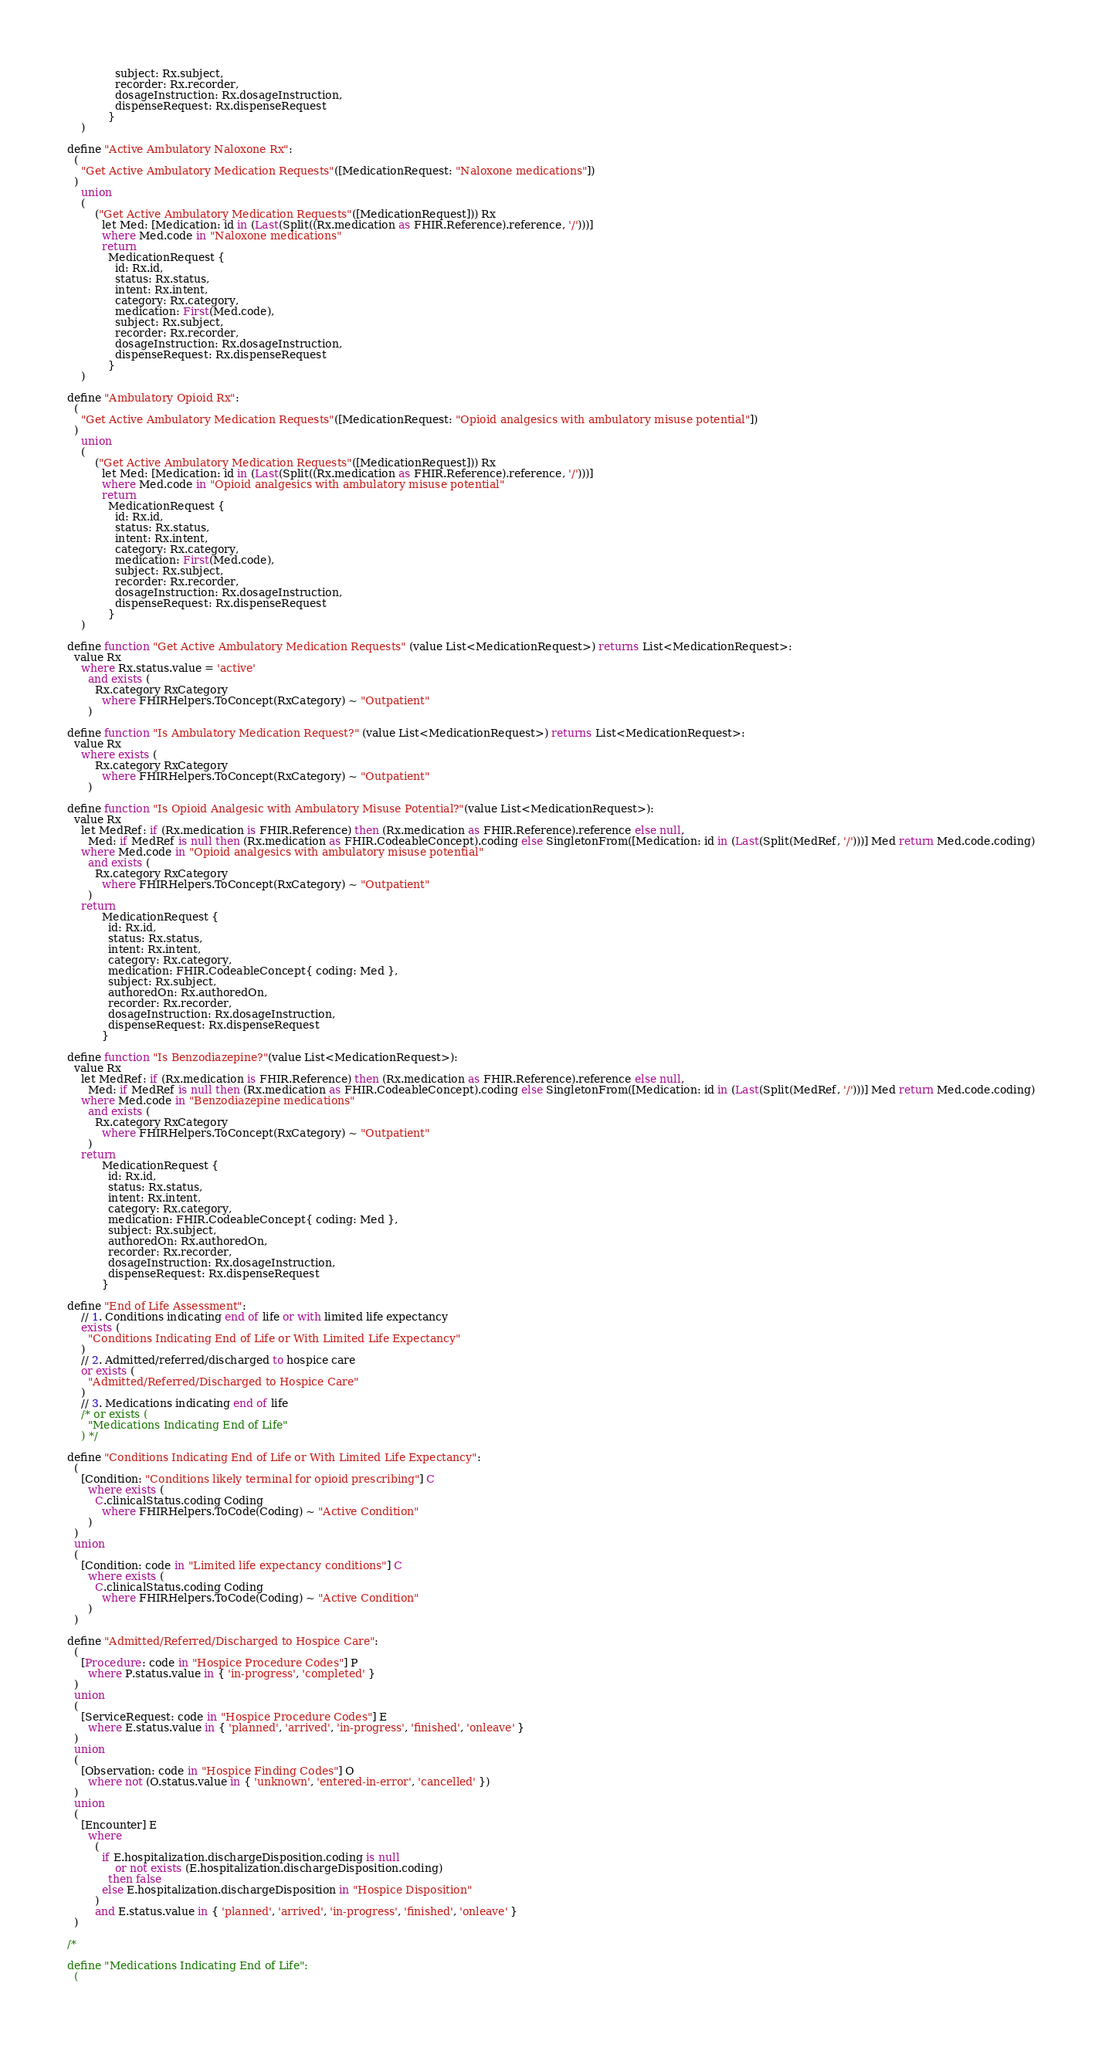<code> <loc_0><loc_0><loc_500><loc_500><_SQL_>              subject: Rx.subject,
              recorder: Rx.recorder,
              dosageInstruction: Rx.dosageInstruction,
              dispenseRequest: Rx.dispenseRequest
            }
    )

define "Active Ambulatory Naloxone Rx":
  (
    "Get Active Ambulatory Medication Requests"([MedicationRequest: "Naloxone medications"])
  )
    union
    (
        ("Get Active Ambulatory Medication Requests"([MedicationRequest])) Rx
          let Med: [Medication: id in (Last(Split((Rx.medication as FHIR.Reference).reference, '/')))]
          where Med.code in "Naloxone medications"
          return
            MedicationRequest {
              id: Rx.id,
              status: Rx.status,
              intent: Rx.intent,
              category: Rx.category,
              medication: First(Med.code),
              subject: Rx.subject,
              recorder: Rx.recorder,
              dosageInstruction: Rx.dosageInstruction,
              dispenseRequest: Rx.dispenseRequest
            }
    )

define "Ambulatory Opioid Rx":
  (
    "Get Active Ambulatory Medication Requests"([MedicationRequest: "Opioid analgesics with ambulatory misuse potential"])
  )
    union
    (
        ("Get Active Ambulatory Medication Requests"([MedicationRequest])) Rx
          let Med: [Medication: id in (Last(Split((Rx.medication as FHIR.Reference).reference, '/')))]
          where Med.code in "Opioid analgesics with ambulatory misuse potential"
          return
            MedicationRequest {
              id: Rx.id,
              status: Rx.status,
              intent: Rx.intent,
              category: Rx.category,
              medication: First(Med.code),
              subject: Rx.subject,
              recorder: Rx.recorder,
              dosageInstruction: Rx.dosageInstruction,
              dispenseRequest: Rx.dispenseRequest
            }
    )

define function "Get Active Ambulatory Medication Requests" (value List<MedicationRequest>) returns List<MedicationRequest>:
  value Rx
    where Rx.status.value = 'active'
      and exists (
        Rx.category RxCategory
          where FHIRHelpers.ToConcept(RxCategory) ~ "Outpatient"
      )

define function "Is Ambulatory Medication Request?" (value List<MedicationRequest>) returns List<MedicationRequest>:
  value Rx
    where exists (
        Rx.category RxCategory
          where FHIRHelpers.ToConcept(RxCategory) ~ "Outpatient"
      )

define function "Is Opioid Analgesic with Ambulatory Misuse Potential?"(value List<MedicationRequest>):
  value Rx
    let MedRef: if (Rx.medication is FHIR.Reference) then (Rx.medication as FHIR.Reference).reference else null,
      Med: if MedRef is null then (Rx.medication as FHIR.CodeableConcept).coding else SingletonFrom([Medication: id in (Last(Split(MedRef, '/')))] Med return Med.code.coding)
    where Med.code in "Opioid analgesics with ambulatory misuse potential"
      and exists (
        Rx.category RxCategory
          where FHIRHelpers.ToConcept(RxCategory) ~ "Outpatient"
      )
    return
          MedicationRequest {
            id: Rx.id,
            status: Rx.status,
            intent: Rx.intent,
            category: Rx.category,
            medication: FHIR.CodeableConcept{ coding: Med },
            subject: Rx.subject,
            authoredOn: Rx.authoredOn,
            recorder: Rx.recorder,
            dosageInstruction: Rx.dosageInstruction,
            dispenseRequest: Rx.dispenseRequest
          }

define function "Is Benzodiazepine?"(value List<MedicationRequest>):
  value Rx
    let MedRef: if (Rx.medication is FHIR.Reference) then (Rx.medication as FHIR.Reference).reference else null,
      Med: if MedRef is null then (Rx.medication as FHIR.CodeableConcept).coding else SingletonFrom([Medication: id in (Last(Split(MedRef, '/')))] Med return Med.code.coding)
    where Med.code in "Benzodiazepine medications"
      and exists (
        Rx.category RxCategory
          where FHIRHelpers.ToConcept(RxCategory) ~ "Outpatient"
      )
    return
          MedicationRequest {
            id: Rx.id,
            status: Rx.status,
            intent: Rx.intent,
            category: Rx.category,
            medication: FHIR.CodeableConcept{ coding: Med },
            subject: Rx.subject,
            authoredOn: Rx.authoredOn,
            recorder: Rx.recorder,
            dosageInstruction: Rx.dosageInstruction,
            dispenseRequest: Rx.dispenseRequest
          }

define "End of Life Assessment":
    // 1. Conditions indicating end of life or with limited life expectancy
    exists (
      "Conditions Indicating End of Life or With Limited Life Expectancy"
    )
    // 2. Admitted/referred/discharged to hospice care
    or exists (
      "Admitted/Referred/Discharged to Hospice Care"
    )
    // 3. Medications indicating end of life
    /* or exists (
      "Medications Indicating End of Life"
    ) */

define "Conditions Indicating End of Life or With Limited Life Expectancy":
  (
    [Condition: "Conditions likely terminal for opioid prescribing"] C
      where exists (
        C.clinicalStatus.coding Coding
          where FHIRHelpers.ToCode(Coding) ~ "Active Condition"
      )
  )
  union
  (
    [Condition: code in "Limited life expectancy conditions"] C
      where exists (
        C.clinicalStatus.coding Coding
          where FHIRHelpers.ToCode(Coding) ~ "Active Condition"
      )
  )

define "Admitted/Referred/Discharged to Hospice Care":
  (
    [Procedure: code in "Hospice Procedure Codes"] P
      where P.status.value in { 'in-progress', 'completed' }
  )
  union
  (
    [ServiceRequest: code in "Hospice Procedure Codes"] E
      where E.status.value in { 'planned', 'arrived', 'in-progress', 'finished', 'onleave' }
  )
  union
  (
    [Observation: code in "Hospice Finding Codes"] O
      where not (O.status.value in { 'unknown', 'entered-in-error', 'cancelled' })
  )
  union
  (
    [Encounter] E
      where
        (
          if E.hospitalization.dischargeDisposition.coding is null
              or not exists (E.hospitalization.dischargeDisposition.coding)
            then false
          else E.hospitalization.dischargeDisposition in "Hospice Disposition"
        )
        and E.status.value in { 'planned', 'arrived', 'in-progress', 'finished', 'onleave' }
  )

/*

define "Medications Indicating End of Life":
  (</code> 